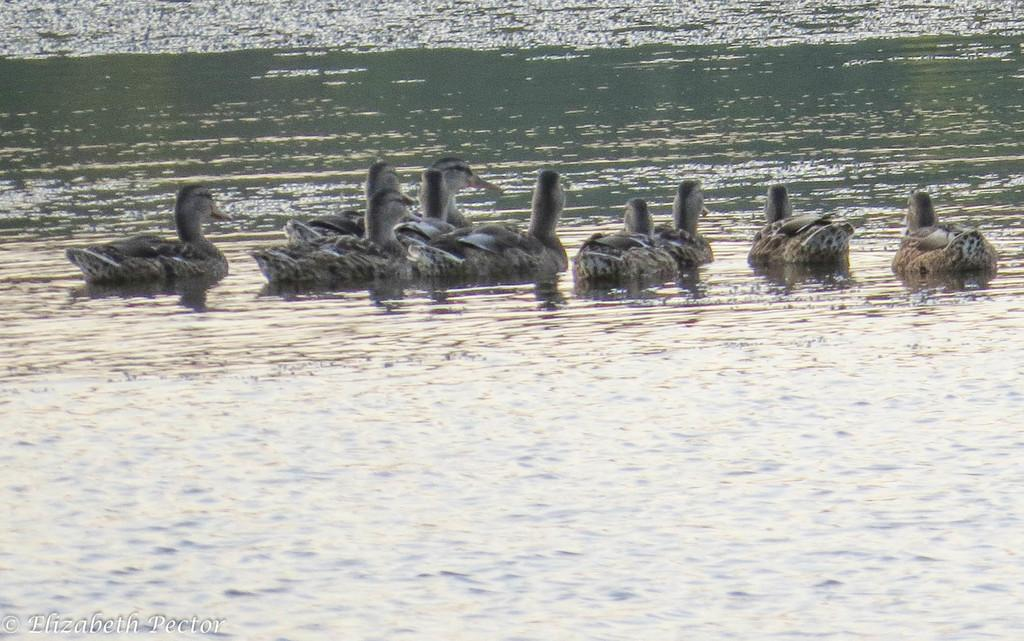What is the primary element in the picture? There is water in the picture. What animals are present in the water? There are ducks in the water. What colors can be observed in the ducks? Some of the ducks are black in color, and some are gray in color. What type of smile can be seen on the grandfather's face in the image? There is no grandfather or smile present in the image; it features water and ducks. 